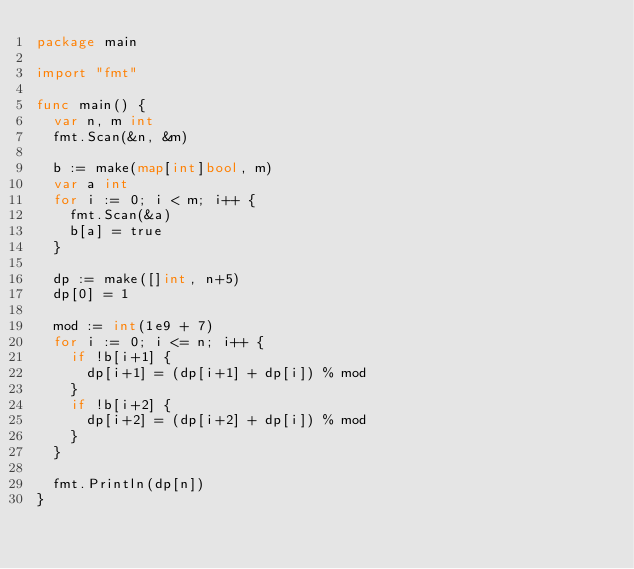<code> <loc_0><loc_0><loc_500><loc_500><_Go_>package main

import "fmt"

func main() {
	var n, m int
	fmt.Scan(&n, &m)

	b := make(map[int]bool, m)
	var a int
	for i := 0; i < m; i++ {
		fmt.Scan(&a)
		b[a] = true
	}

	dp := make([]int, n+5)
	dp[0] = 1

	mod := int(1e9 + 7)
	for i := 0; i <= n; i++ {
		if !b[i+1] {
			dp[i+1] = (dp[i+1] + dp[i]) % mod
		}
		if !b[i+2] {
			dp[i+2] = (dp[i+2] + dp[i]) % mod
		}
	}

	fmt.Println(dp[n])
}
</code> 